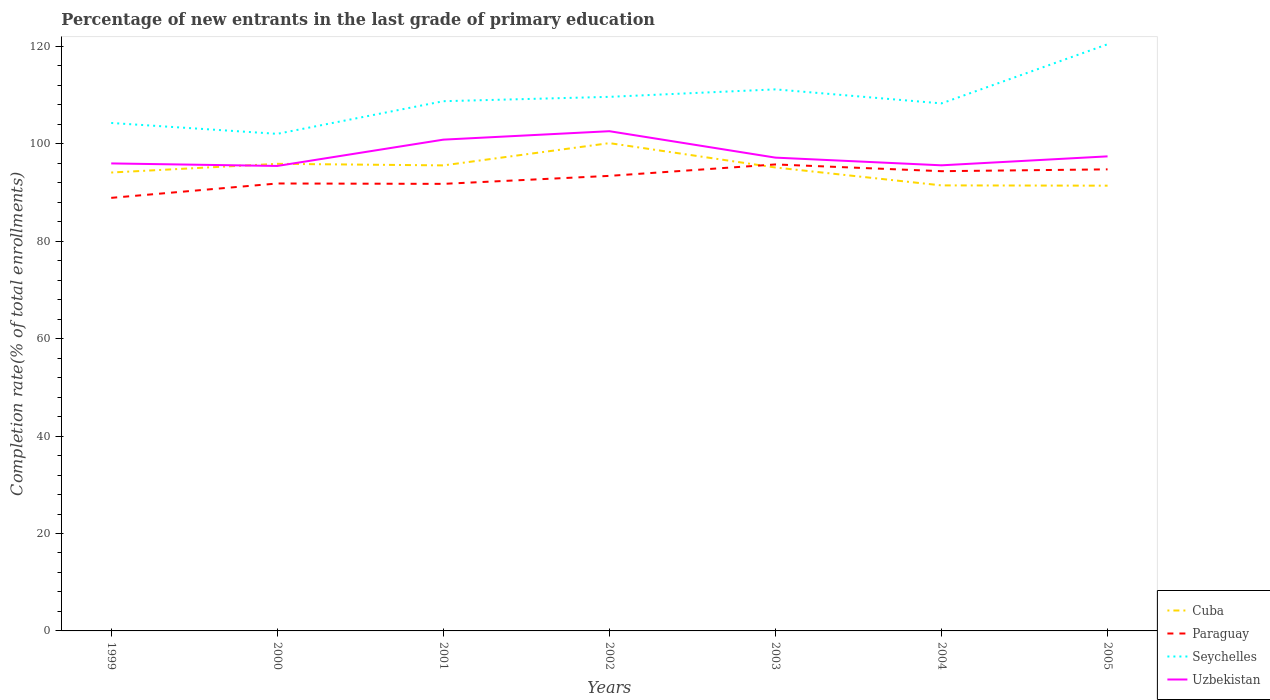How many different coloured lines are there?
Your answer should be compact. 4. Across all years, what is the maximum percentage of new entrants in Paraguay?
Provide a short and direct response. 88.92. In which year was the percentage of new entrants in Cuba maximum?
Keep it short and to the point. 2005. What is the total percentage of new entrants in Cuba in the graph?
Offer a very short reply. 4.11. What is the difference between the highest and the second highest percentage of new entrants in Paraguay?
Keep it short and to the point. 6.86. Is the percentage of new entrants in Uzbekistan strictly greater than the percentage of new entrants in Paraguay over the years?
Your response must be concise. No. Are the values on the major ticks of Y-axis written in scientific E-notation?
Provide a succinct answer. No. Where does the legend appear in the graph?
Offer a very short reply. Bottom right. What is the title of the graph?
Make the answer very short. Percentage of new entrants in the last grade of primary education. Does "Belgium" appear as one of the legend labels in the graph?
Offer a terse response. No. What is the label or title of the Y-axis?
Offer a terse response. Completion rate(% of total enrollments). What is the Completion rate(% of total enrollments) of Cuba in 1999?
Ensure brevity in your answer.  94.12. What is the Completion rate(% of total enrollments) in Paraguay in 1999?
Provide a succinct answer. 88.92. What is the Completion rate(% of total enrollments) in Seychelles in 1999?
Keep it short and to the point. 104.3. What is the Completion rate(% of total enrollments) of Uzbekistan in 1999?
Offer a terse response. 95.99. What is the Completion rate(% of total enrollments) in Cuba in 2000?
Provide a succinct answer. 95.91. What is the Completion rate(% of total enrollments) of Paraguay in 2000?
Provide a succinct answer. 91.87. What is the Completion rate(% of total enrollments) of Seychelles in 2000?
Provide a succinct answer. 102.06. What is the Completion rate(% of total enrollments) in Uzbekistan in 2000?
Offer a terse response. 95.47. What is the Completion rate(% of total enrollments) in Cuba in 2001?
Make the answer very short. 95.59. What is the Completion rate(% of total enrollments) in Paraguay in 2001?
Ensure brevity in your answer.  91.79. What is the Completion rate(% of total enrollments) in Seychelles in 2001?
Make the answer very short. 108.76. What is the Completion rate(% of total enrollments) in Uzbekistan in 2001?
Keep it short and to the point. 100.87. What is the Completion rate(% of total enrollments) in Cuba in 2002?
Ensure brevity in your answer.  100.16. What is the Completion rate(% of total enrollments) in Paraguay in 2002?
Ensure brevity in your answer.  93.43. What is the Completion rate(% of total enrollments) of Seychelles in 2002?
Ensure brevity in your answer.  109.66. What is the Completion rate(% of total enrollments) of Uzbekistan in 2002?
Keep it short and to the point. 102.61. What is the Completion rate(% of total enrollments) of Cuba in 2003?
Offer a very short reply. 95.15. What is the Completion rate(% of total enrollments) in Paraguay in 2003?
Offer a terse response. 95.78. What is the Completion rate(% of total enrollments) of Seychelles in 2003?
Make the answer very short. 111.19. What is the Completion rate(% of total enrollments) in Uzbekistan in 2003?
Your answer should be compact. 97.18. What is the Completion rate(% of total enrollments) in Cuba in 2004?
Provide a short and direct response. 91.48. What is the Completion rate(% of total enrollments) of Paraguay in 2004?
Provide a succinct answer. 94.4. What is the Completion rate(% of total enrollments) in Seychelles in 2004?
Provide a succinct answer. 108.32. What is the Completion rate(% of total enrollments) of Uzbekistan in 2004?
Provide a succinct answer. 95.6. What is the Completion rate(% of total enrollments) in Cuba in 2005?
Make the answer very short. 91.42. What is the Completion rate(% of total enrollments) of Paraguay in 2005?
Offer a terse response. 94.77. What is the Completion rate(% of total enrollments) of Seychelles in 2005?
Provide a succinct answer. 120.46. What is the Completion rate(% of total enrollments) of Uzbekistan in 2005?
Ensure brevity in your answer.  97.44. Across all years, what is the maximum Completion rate(% of total enrollments) of Cuba?
Ensure brevity in your answer.  100.16. Across all years, what is the maximum Completion rate(% of total enrollments) in Paraguay?
Provide a succinct answer. 95.78. Across all years, what is the maximum Completion rate(% of total enrollments) of Seychelles?
Provide a short and direct response. 120.46. Across all years, what is the maximum Completion rate(% of total enrollments) of Uzbekistan?
Ensure brevity in your answer.  102.61. Across all years, what is the minimum Completion rate(% of total enrollments) of Cuba?
Keep it short and to the point. 91.42. Across all years, what is the minimum Completion rate(% of total enrollments) in Paraguay?
Your answer should be compact. 88.92. Across all years, what is the minimum Completion rate(% of total enrollments) in Seychelles?
Provide a succinct answer. 102.06. Across all years, what is the minimum Completion rate(% of total enrollments) in Uzbekistan?
Make the answer very short. 95.47. What is the total Completion rate(% of total enrollments) of Cuba in the graph?
Provide a succinct answer. 663.83. What is the total Completion rate(% of total enrollments) in Paraguay in the graph?
Ensure brevity in your answer.  650.96. What is the total Completion rate(% of total enrollments) of Seychelles in the graph?
Your response must be concise. 764.75. What is the total Completion rate(% of total enrollments) of Uzbekistan in the graph?
Provide a succinct answer. 685.16. What is the difference between the Completion rate(% of total enrollments) in Cuba in 1999 and that in 2000?
Make the answer very short. -1.79. What is the difference between the Completion rate(% of total enrollments) in Paraguay in 1999 and that in 2000?
Offer a very short reply. -2.95. What is the difference between the Completion rate(% of total enrollments) in Seychelles in 1999 and that in 2000?
Your response must be concise. 2.23. What is the difference between the Completion rate(% of total enrollments) in Uzbekistan in 1999 and that in 2000?
Offer a terse response. 0.52. What is the difference between the Completion rate(% of total enrollments) of Cuba in 1999 and that in 2001?
Keep it short and to the point. -1.46. What is the difference between the Completion rate(% of total enrollments) of Paraguay in 1999 and that in 2001?
Give a very brief answer. -2.87. What is the difference between the Completion rate(% of total enrollments) in Seychelles in 1999 and that in 2001?
Provide a short and direct response. -4.47. What is the difference between the Completion rate(% of total enrollments) of Uzbekistan in 1999 and that in 2001?
Offer a terse response. -4.88. What is the difference between the Completion rate(% of total enrollments) of Cuba in 1999 and that in 2002?
Provide a succinct answer. -6.04. What is the difference between the Completion rate(% of total enrollments) of Paraguay in 1999 and that in 2002?
Your answer should be very brief. -4.51. What is the difference between the Completion rate(% of total enrollments) in Seychelles in 1999 and that in 2002?
Keep it short and to the point. -5.36. What is the difference between the Completion rate(% of total enrollments) of Uzbekistan in 1999 and that in 2002?
Your response must be concise. -6.62. What is the difference between the Completion rate(% of total enrollments) in Cuba in 1999 and that in 2003?
Provide a short and direct response. -1.03. What is the difference between the Completion rate(% of total enrollments) in Paraguay in 1999 and that in 2003?
Keep it short and to the point. -6.86. What is the difference between the Completion rate(% of total enrollments) in Seychelles in 1999 and that in 2003?
Provide a short and direct response. -6.9. What is the difference between the Completion rate(% of total enrollments) in Uzbekistan in 1999 and that in 2003?
Make the answer very short. -1.19. What is the difference between the Completion rate(% of total enrollments) of Cuba in 1999 and that in 2004?
Offer a very short reply. 2.64. What is the difference between the Completion rate(% of total enrollments) in Paraguay in 1999 and that in 2004?
Provide a succinct answer. -5.48. What is the difference between the Completion rate(% of total enrollments) of Seychelles in 1999 and that in 2004?
Offer a very short reply. -4.02. What is the difference between the Completion rate(% of total enrollments) in Uzbekistan in 1999 and that in 2004?
Your response must be concise. 0.39. What is the difference between the Completion rate(% of total enrollments) of Cuba in 1999 and that in 2005?
Keep it short and to the point. 2.7. What is the difference between the Completion rate(% of total enrollments) in Paraguay in 1999 and that in 2005?
Give a very brief answer. -5.85. What is the difference between the Completion rate(% of total enrollments) of Seychelles in 1999 and that in 2005?
Offer a terse response. -16.16. What is the difference between the Completion rate(% of total enrollments) in Uzbekistan in 1999 and that in 2005?
Make the answer very short. -1.45. What is the difference between the Completion rate(% of total enrollments) in Cuba in 2000 and that in 2001?
Ensure brevity in your answer.  0.32. What is the difference between the Completion rate(% of total enrollments) of Paraguay in 2000 and that in 2001?
Keep it short and to the point. 0.08. What is the difference between the Completion rate(% of total enrollments) in Seychelles in 2000 and that in 2001?
Provide a succinct answer. -6.7. What is the difference between the Completion rate(% of total enrollments) of Uzbekistan in 2000 and that in 2001?
Offer a terse response. -5.4. What is the difference between the Completion rate(% of total enrollments) of Cuba in 2000 and that in 2002?
Offer a very short reply. -4.25. What is the difference between the Completion rate(% of total enrollments) in Paraguay in 2000 and that in 2002?
Offer a very short reply. -1.56. What is the difference between the Completion rate(% of total enrollments) of Seychelles in 2000 and that in 2002?
Provide a short and direct response. -7.6. What is the difference between the Completion rate(% of total enrollments) in Uzbekistan in 2000 and that in 2002?
Your answer should be very brief. -7.14. What is the difference between the Completion rate(% of total enrollments) in Cuba in 2000 and that in 2003?
Your answer should be compact. 0.75. What is the difference between the Completion rate(% of total enrollments) of Paraguay in 2000 and that in 2003?
Provide a succinct answer. -3.91. What is the difference between the Completion rate(% of total enrollments) of Seychelles in 2000 and that in 2003?
Your response must be concise. -9.13. What is the difference between the Completion rate(% of total enrollments) of Uzbekistan in 2000 and that in 2003?
Keep it short and to the point. -1.71. What is the difference between the Completion rate(% of total enrollments) of Cuba in 2000 and that in 2004?
Provide a short and direct response. 4.43. What is the difference between the Completion rate(% of total enrollments) in Paraguay in 2000 and that in 2004?
Ensure brevity in your answer.  -2.53. What is the difference between the Completion rate(% of total enrollments) of Seychelles in 2000 and that in 2004?
Offer a terse response. -6.25. What is the difference between the Completion rate(% of total enrollments) of Uzbekistan in 2000 and that in 2004?
Keep it short and to the point. -0.13. What is the difference between the Completion rate(% of total enrollments) in Cuba in 2000 and that in 2005?
Provide a succinct answer. 4.48. What is the difference between the Completion rate(% of total enrollments) in Paraguay in 2000 and that in 2005?
Provide a succinct answer. -2.9. What is the difference between the Completion rate(% of total enrollments) in Seychelles in 2000 and that in 2005?
Provide a short and direct response. -18.39. What is the difference between the Completion rate(% of total enrollments) in Uzbekistan in 2000 and that in 2005?
Make the answer very short. -1.97. What is the difference between the Completion rate(% of total enrollments) in Cuba in 2001 and that in 2002?
Give a very brief answer. -4.57. What is the difference between the Completion rate(% of total enrollments) of Paraguay in 2001 and that in 2002?
Ensure brevity in your answer.  -1.64. What is the difference between the Completion rate(% of total enrollments) of Seychelles in 2001 and that in 2002?
Provide a short and direct response. -0.9. What is the difference between the Completion rate(% of total enrollments) in Uzbekistan in 2001 and that in 2002?
Provide a short and direct response. -1.73. What is the difference between the Completion rate(% of total enrollments) in Cuba in 2001 and that in 2003?
Offer a terse response. 0.43. What is the difference between the Completion rate(% of total enrollments) in Paraguay in 2001 and that in 2003?
Provide a short and direct response. -3.99. What is the difference between the Completion rate(% of total enrollments) in Seychelles in 2001 and that in 2003?
Give a very brief answer. -2.43. What is the difference between the Completion rate(% of total enrollments) in Uzbekistan in 2001 and that in 2003?
Ensure brevity in your answer.  3.69. What is the difference between the Completion rate(% of total enrollments) of Cuba in 2001 and that in 2004?
Your response must be concise. 4.11. What is the difference between the Completion rate(% of total enrollments) of Paraguay in 2001 and that in 2004?
Your response must be concise. -2.61. What is the difference between the Completion rate(% of total enrollments) of Seychelles in 2001 and that in 2004?
Give a very brief answer. 0.45. What is the difference between the Completion rate(% of total enrollments) in Uzbekistan in 2001 and that in 2004?
Your answer should be very brief. 5.27. What is the difference between the Completion rate(% of total enrollments) of Cuba in 2001 and that in 2005?
Provide a succinct answer. 4.16. What is the difference between the Completion rate(% of total enrollments) in Paraguay in 2001 and that in 2005?
Your answer should be very brief. -2.98. What is the difference between the Completion rate(% of total enrollments) of Seychelles in 2001 and that in 2005?
Provide a succinct answer. -11.69. What is the difference between the Completion rate(% of total enrollments) in Uzbekistan in 2001 and that in 2005?
Your answer should be compact. 3.43. What is the difference between the Completion rate(% of total enrollments) in Cuba in 2002 and that in 2003?
Your answer should be very brief. 5. What is the difference between the Completion rate(% of total enrollments) in Paraguay in 2002 and that in 2003?
Offer a very short reply. -2.35. What is the difference between the Completion rate(% of total enrollments) in Seychelles in 2002 and that in 2003?
Keep it short and to the point. -1.53. What is the difference between the Completion rate(% of total enrollments) of Uzbekistan in 2002 and that in 2003?
Your response must be concise. 5.43. What is the difference between the Completion rate(% of total enrollments) of Cuba in 2002 and that in 2004?
Offer a very short reply. 8.68. What is the difference between the Completion rate(% of total enrollments) in Paraguay in 2002 and that in 2004?
Offer a terse response. -0.96. What is the difference between the Completion rate(% of total enrollments) of Seychelles in 2002 and that in 2004?
Your answer should be compact. 1.34. What is the difference between the Completion rate(% of total enrollments) in Uzbekistan in 2002 and that in 2004?
Keep it short and to the point. 7.01. What is the difference between the Completion rate(% of total enrollments) of Cuba in 2002 and that in 2005?
Your answer should be very brief. 8.73. What is the difference between the Completion rate(% of total enrollments) in Paraguay in 2002 and that in 2005?
Offer a very short reply. -1.34. What is the difference between the Completion rate(% of total enrollments) of Seychelles in 2002 and that in 2005?
Ensure brevity in your answer.  -10.8. What is the difference between the Completion rate(% of total enrollments) of Uzbekistan in 2002 and that in 2005?
Your answer should be compact. 5.17. What is the difference between the Completion rate(% of total enrollments) of Cuba in 2003 and that in 2004?
Give a very brief answer. 3.68. What is the difference between the Completion rate(% of total enrollments) of Paraguay in 2003 and that in 2004?
Offer a terse response. 1.38. What is the difference between the Completion rate(% of total enrollments) in Seychelles in 2003 and that in 2004?
Your answer should be compact. 2.88. What is the difference between the Completion rate(% of total enrollments) of Uzbekistan in 2003 and that in 2004?
Ensure brevity in your answer.  1.58. What is the difference between the Completion rate(% of total enrollments) in Cuba in 2003 and that in 2005?
Offer a very short reply. 3.73. What is the difference between the Completion rate(% of total enrollments) of Paraguay in 2003 and that in 2005?
Offer a very short reply. 1.01. What is the difference between the Completion rate(% of total enrollments) in Seychelles in 2003 and that in 2005?
Keep it short and to the point. -9.26. What is the difference between the Completion rate(% of total enrollments) of Uzbekistan in 2003 and that in 2005?
Your response must be concise. -0.26. What is the difference between the Completion rate(% of total enrollments) in Cuba in 2004 and that in 2005?
Make the answer very short. 0.06. What is the difference between the Completion rate(% of total enrollments) in Paraguay in 2004 and that in 2005?
Your answer should be compact. -0.37. What is the difference between the Completion rate(% of total enrollments) of Seychelles in 2004 and that in 2005?
Your response must be concise. -12.14. What is the difference between the Completion rate(% of total enrollments) in Uzbekistan in 2004 and that in 2005?
Your answer should be very brief. -1.84. What is the difference between the Completion rate(% of total enrollments) in Cuba in 1999 and the Completion rate(% of total enrollments) in Paraguay in 2000?
Provide a short and direct response. 2.25. What is the difference between the Completion rate(% of total enrollments) of Cuba in 1999 and the Completion rate(% of total enrollments) of Seychelles in 2000?
Make the answer very short. -7.94. What is the difference between the Completion rate(% of total enrollments) of Cuba in 1999 and the Completion rate(% of total enrollments) of Uzbekistan in 2000?
Ensure brevity in your answer.  -1.35. What is the difference between the Completion rate(% of total enrollments) of Paraguay in 1999 and the Completion rate(% of total enrollments) of Seychelles in 2000?
Provide a succinct answer. -13.14. What is the difference between the Completion rate(% of total enrollments) of Paraguay in 1999 and the Completion rate(% of total enrollments) of Uzbekistan in 2000?
Your answer should be very brief. -6.55. What is the difference between the Completion rate(% of total enrollments) in Seychelles in 1999 and the Completion rate(% of total enrollments) in Uzbekistan in 2000?
Your answer should be very brief. 8.83. What is the difference between the Completion rate(% of total enrollments) in Cuba in 1999 and the Completion rate(% of total enrollments) in Paraguay in 2001?
Make the answer very short. 2.33. What is the difference between the Completion rate(% of total enrollments) in Cuba in 1999 and the Completion rate(% of total enrollments) in Seychelles in 2001?
Give a very brief answer. -14.64. What is the difference between the Completion rate(% of total enrollments) of Cuba in 1999 and the Completion rate(% of total enrollments) of Uzbekistan in 2001?
Make the answer very short. -6.75. What is the difference between the Completion rate(% of total enrollments) in Paraguay in 1999 and the Completion rate(% of total enrollments) in Seychelles in 2001?
Provide a succinct answer. -19.84. What is the difference between the Completion rate(% of total enrollments) in Paraguay in 1999 and the Completion rate(% of total enrollments) in Uzbekistan in 2001?
Your response must be concise. -11.95. What is the difference between the Completion rate(% of total enrollments) of Seychelles in 1999 and the Completion rate(% of total enrollments) of Uzbekistan in 2001?
Your answer should be very brief. 3.43. What is the difference between the Completion rate(% of total enrollments) in Cuba in 1999 and the Completion rate(% of total enrollments) in Paraguay in 2002?
Make the answer very short. 0.69. What is the difference between the Completion rate(% of total enrollments) of Cuba in 1999 and the Completion rate(% of total enrollments) of Seychelles in 2002?
Offer a very short reply. -15.54. What is the difference between the Completion rate(% of total enrollments) in Cuba in 1999 and the Completion rate(% of total enrollments) in Uzbekistan in 2002?
Make the answer very short. -8.49. What is the difference between the Completion rate(% of total enrollments) of Paraguay in 1999 and the Completion rate(% of total enrollments) of Seychelles in 2002?
Offer a terse response. -20.74. What is the difference between the Completion rate(% of total enrollments) of Paraguay in 1999 and the Completion rate(% of total enrollments) of Uzbekistan in 2002?
Keep it short and to the point. -13.69. What is the difference between the Completion rate(% of total enrollments) of Seychelles in 1999 and the Completion rate(% of total enrollments) of Uzbekistan in 2002?
Offer a very short reply. 1.69. What is the difference between the Completion rate(% of total enrollments) in Cuba in 1999 and the Completion rate(% of total enrollments) in Paraguay in 2003?
Provide a short and direct response. -1.66. What is the difference between the Completion rate(% of total enrollments) in Cuba in 1999 and the Completion rate(% of total enrollments) in Seychelles in 2003?
Offer a very short reply. -17.07. What is the difference between the Completion rate(% of total enrollments) in Cuba in 1999 and the Completion rate(% of total enrollments) in Uzbekistan in 2003?
Offer a terse response. -3.06. What is the difference between the Completion rate(% of total enrollments) of Paraguay in 1999 and the Completion rate(% of total enrollments) of Seychelles in 2003?
Give a very brief answer. -22.27. What is the difference between the Completion rate(% of total enrollments) in Paraguay in 1999 and the Completion rate(% of total enrollments) in Uzbekistan in 2003?
Provide a short and direct response. -8.26. What is the difference between the Completion rate(% of total enrollments) in Seychelles in 1999 and the Completion rate(% of total enrollments) in Uzbekistan in 2003?
Give a very brief answer. 7.12. What is the difference between the Completion rate(% of total enrollments) in Cuba in 1999 and the Completion rate(% of total enrollments) in Paraguay in 2004?
Provide a short and direct response. -0.28. What is the difference between the Completion rate(% of total enrollments) in Cuba in 1999 and the Completion rate(% of total enrollments) in Seychelles in 2004?
Ensure brevity in your answer.  -14.2. What is the difference between the Completion rate(% of total enrollments) of Cuba in 1999 and the Completion rate(% of total enrollments) of Uzbekistan in 2004?
Give a very brief answer. -1.48. What is the difference between the Completion rate(% of total enrollments) in Paraguay in 1999 and the Completion rate(% of total enrollments) in Seychelles in 2004?
Provide a short and direct response. -19.4. What is the difference between the Completion rate(% of total enrollments) of Paraguay in 1999 and the Completion rate(% of total enrollments) of Uzbekistan in 2004?
Give a very brief answer. -6.68. What is the difference between the Completion rate(% of total enrollments) of Seychelles in 1999 and the Completion rate(% of total enrollments) of Uzbekistan in 2004?
Your answer should be compact. 8.7. What is the difference between the Completion rate(% of total enrollments) of Cuba in 1999 and the Completion rate(% of total enrollments) of Paraguay in 2005?
Provide a succinct answer. -0.65. What is the difference between the Completion rate(% of total enrollments) of Cuba in 1999 and the Completion rate(% of total enrollments) of Seychelles in 2005?
Provide a succinct answer. -26.34. What is the difference between the Completion rate(% of total enrollments) of Cuba in 1999 and the Completion rate(% of total enrollments) of Uzbekistan in 2005?
Your answer should be very brief. -3.32. What is the difference between the Completion rate(% of total enrollments) of Paraguay in 1999 and the Completion rate(% of total enrollments) of Seychelles in 2005?
Provide a short and direct response. -31.54. What is the difference between the Completion rate(% of total enrollments) in Paraguay in 1999 and the Completion rate(% of total enrollments) in Uzbekistan in 2005?
Offer a very short reply. -8.52. What is the difference between the Completion rate(% of total enrollments) in Seychelles in 1999 and the Completion rate(% of total enrollments) in Uzbekistan in 2005?
Your answer should be compact. 6.86. What is the difference between the Completion rate(% of total enrollments) of Cuba in 2000 and the Completion rate(% of total enrollments) of Paraguay in 2001?
Your answer should be compact. 4.12. What is the difference between the Completion rate(% of total enrollments) in Cuba in 2000 and the Completion rate(% of total enrollments) in Seychelles in 2001?
Keep it short and to the point. -12.86. What is the difference between the Completion rate(% of total enrollments) in Cuba in 2000 and the Completion rate(% of total enrollments) in Uzbekistan in 2001?
Provide a succinct answer. -4.96. What is the difference between the Completion rate(% of total enrollments) of Paraguay in 2000 and the Completion rate(% of total enrollments) of Seychelles in 2001?
Your response must be concise. -16.89. What is the difference between the Completion rate(% of total enrollments) in Paraguay in 2000 and the Completion rate(% of total enrollments) in Uzbekistan in 2001?
Ensure brevity in your answer.  -9. What is the difference between the Completion rate(% of total enrollments) of Seychelles in 2000 and the Completion rate(% of total enrollments) of Uzbekistan in 2001?
Make the answer very short. 1.19. What is the difference between the Completion rate(% of total enrollments) of Cuba in 2000 and the Completion rate(% of total enrollments) of Paraguay in 2002?
Your answer should be very brief. 2.47. What is the difference between the Completion rate(% of total enrollments) of Cuba in 2000 and the Completion rate(% of total enrollments) of Seychelles in 2002?
Offer a very short reply. -13.75. What is the difference between the Completion rate(% of total enrollments) of Cuba in 2000 and the Completion rate(% of total enrollments) of Uzbekistan in 2002?
Provide a succinct answer. -6.7. What is the difference between the Completion rate(% of total enrollments) in Paraguay in 2000 and the Completion rate(% of total enrollments) in Seychelles in 2002?
Provide a short and direct response. -17.79. What is the difference between the Completion rate(% of total enrollments) in Paraguay in 2000 and the Completion rate(% of total enrollments) in Uzbekistan in 2002?
Your answer should be compact. -10.74. What is the difference between the Completion rate(% of total enrollments) in Seychelles in 2000 and the Completion rate(% of total enrollments) in Uzbekistan in 2002?
Make the answer very short. -0.54. What is the difference between the Completion rate(% of total enrollments) in Cuba in 2000 and the Completion rate(% of total enrollments) in Paraguay in 2003?
Your answer should be compact. 0.13. What is the difference between the Completion rate(% of total enrollments) of Cuba in 2000 and the Completion rate(% of total enrollments) of Seychelles in 2003?
Your answer should be compact. -15.29. What is the difference between the Completion rate(% of total enrollments) of Cuba in 2000 and the Completion rate(% of total enrollments) of Uzbekistan in 2003?
Your response must be concise. -1.27. What is the difference between the Completion rate(% of total enrollments) of Paraguay in 2000 and the Completion rate(% of total enrollments) of Seychelles in 2003?
Offer a very short reply. -19.32. What is the difference between the Completion rate(% of total enrollments) of Paraguay in 2000 and the Completion rate(% of total enrollments) of Uzbekistan in 2003?
Offer a terse response. -5.31. What is the difference between the Completion rate(% of total enrollments) of Seychelles in 2000 and the Completion rate(% of total enrollments) of Uzbekistan in 2003?
Your answer should be compact. 4.88. What is the difference between the Completion rate(% of total enrollments) of Cuba in 2000 and the Completion rate(% of total enrollments) of Paraguay in 2004?
Make the answer very short. 1.51. What is the difference between the Completion rate(% of total enrollments) of Cuba in 2000 and the Completion rate(% of total enrollments) of Seychelles in 2004?
Provide a short and direct response. -12.41. What is the difference between the Completion rate(% of total enrollments) of Cuba in 2000 and the Completion rate(% of total enrollments) of Uzbekistan in 2004?
Give a very brief answer. 0.31. What is the difference between the Completion rate(% of total enrollments) of Paraguay in 2000 and the Completion rate(% of total enrollments) of Seychelles in 2004?
Ensure brevity in your answer.  -16.45. What is the difference between the Completion rate(% of total enrollments) of Paraguay in 2000 and the Completion rate(% of total enrollments) of Uzbekistan in 2004?
Give a very brief answer. -3.73. What is the difference between the Completion rate(% of total enrollments) of Seychelles in 2000 and the Completion rate(% of total enrollments) of Uzbekistan in 2004?
Your response must be concise. 6.46. What is the difference between the Completion rate(% of total enrollments) in Cuba in 2000 and the Completion rate(% of total enrollments) in Paraguay in 2005?
Keep it short and to the point. 1.14. What is the difference between the Completion rate(% of total enrollments) in Cuba in 2000 and the Completion rate(% of total enrollments) in Seychelles in 2005?
Keep it short and to the point. -24.55. What is the difference between the Completion rate(% of total enrollments) in Cuba in 2000 and the Completion rate(% of total enrollments) in Uzbekistan in 2005?
Ensure brevity in your answer.  -1.53. What is the difference between the Completion rate(% of total enrollments) in Paraguay in 2000 and the Completion rate(% of total enrollments) in Seychelles in 2005?
Offer a terse response. -28.59. What is the difference between the Completion rate(% of total enrollments) of Paraguay in 2000 and the Completion rate(% of total enrollments) of Uzbekistan in 2005?
Offer a very short reply. -5.57. What is the difference between the Completion rate(% of total enrollments) in Seychelles in 2000 and the Completion rate(% of total enrollments) in Uzbekistan in 2005?
Make the answer very short. 4.62. What is the difference between the Completion rate(% of total enrollments) in Cuba in 2001 and the Completion rate(% of total enrollments) in Paraguay in 2002?
Provide a succinct answer. 2.15. What is the difference between the Completion rate(% of total enrollments) of Cuba in 2001 and the Completion rate(% of total enrollments) of Seychelles in 2002?
Your response must be concise. -14.07. What is the difference between the Completion rate(% of total enrollments) of Cuba in 2001 and the Completion rate(% of total enrollments) of Uzbekistan in 2002?
Offer a terse response. -7.02. What is the difference between the Completion rate(% of total enrollments) in Paraguay in 2001 and the Completion rate(% of total enrollments) in Seychelles in 2002?
Your answer should be very brief. -17.87. What is the difference between the Completion rate(% of total enrollments) of Paraguay in 2001 and the Completion rate(% of total enrollments) of Uzbekistan in 2002?
Provide a short and direct response. -10.81. What is the difference between the Completion rate(% of total enrollments) of Seychelles in 2001 and the Completion rate(% of total enrollments) of Uzbekistan in 2002?
Ensure brevity in your answer.  6.16. What is the difference between the Completion rate(% of total enrollments) in Cuba in 2001 and the Completion rate(% of total enrollments) in Paraguay in 2003?
Ensure brevity in your answer.  -0.2. What is the difference between the Completion rate(% of total enrollments) of Cuba in 2001 and the Completion rate(% of total enrollments) of Seychelles in 2003?
Your response must be concise. -15.61. What is the difference between the Completion rate(% of total enrollments) in Cuba in 2001 and the Completion rate(% of total enrollments) in Uzbekistan in 2003?
Keep it short and to the point. -1.59. What is the difference between the Completion rate(% of total enrollments) of Paraguay in 2001 and the Completion rate(% of total enrollments) of Seychelles in 2003?
Ensure brevity in your answer.  -19.4. What is the difference between the Completion rate(% of total enrollments) in Paraguay in 2001 and the Completion rate(% of total enrollments) in Uzbekistan in 2003?
Your answer should be compact. -5.39. What is the difference between the Completion rate(% of total enrollments) in Seychelles in 2001 and the Completion rate(% of total enrollments) in Uzbekistan in 2003?
Keep it short and to the point. 11.58. What is the difference between the Completion rate(% of total enrollments) of Cuba in 2001 and the Completion rate(% of total enrollments) of Paraguay in 2004?
Provide a short and direct response. 1.19. What is the difference between the Completion rate(% of total enrollments) of Cuba in 2001 and the Completion rate(% of total enrollments) of Seychelles in 2004?
Offer a very short reply. -12.73. What is the difference between the Completion rate(% of total enrollments) in Cuba in 2001 and the Completion rate(% of total enrollments) in Uzbekistan in 2004?
Keep it short and to the point. -0.01. What is the difference between the Completion rate(% of total enrollments) of Paraguay in 2001 and the Completion rate(% of total enrollments) of Seychelles in 2004?
Your answer should be compact. -16.52. What is the difference between the Completion rate(% of total enrollments) of Paraguay in 2001 and the Completion rate(% of total enrollments) of Uzbekistan in 2004?
Provide a succinct answer. -3.81. What is the difference between the Completion rate(% of total enrollments) in Seychelles in 2001 and the Completion rate(% of total enrollments) in Uzbekistan in 2004?
Ensure brevity in your answer.  13.16. What is the difference between the Completion rate(% of total enrollments) of Cuba in 2001 and the Completion rate(% of total enrollments) of Paraguay in 2005?
Provide a succinct answer. 0.81. What is the difference between the Completion rate(% of total enrollments) of Cuba in 2001 and the Completion rate(% of total enrollments) of Seychelles in 2005?
Give a very brief answer. -24.87. What is the difference between the Completion rate(% of total enrollments) in Cuba in 2001 and the Completion rate(% of total enrollments) in Uzbekistan in 2005?
Provide a succinct answer. -1.85. What is the difference between the Completion rate(% of total enrollments) in Paraguay in 2001 and the Completion rate(% of total enrollments) in Seychelles in 2005?
Ensure brevity in your answer.  -28.67. What is the difference between the Completion rate(% of total enrollments) of Paraguay in 2001 and the Completion rate(% of total enrollments) of Uzbekistan in 2005?
Keep it short and to the point. -5.65. What is the difference between the Completion rate(% of total enrollments) in Seychelles in 2001 and the Completion rate(% of total enrollments) in Uzbekistan in 2005?
Your answer should be very brief. 11.32. What is the difference between the Completion rate(% of total enrollments) of Cuba in 2002 and the Completion rate(% of total enrollments) of Paraguay in 2003?
Offer a terse response. 4.38. What is the difference between the Completion rate(% of total enrollments) of Cuba in 2002 and the Completion rate(% of total enrollments) of Seychelles in 2003?
Offer a very short reply. -11.04. What is the difference between the Completion rate(% of total enrollments) in Cuba in 2002 and the Completion rate(% of total enrollments) in Uzbekistan in 2003?
Keep it short and to the point. 2.98. What is the difference between the Completion rate(% of total enrollments) in Paraguay in 2002 and the Completion rate(% of total enrollments) in Seychelles in 2003?
Make the answer very short. -17.76. What is the difference between the Completion rate(% of total enrollments) of Paraguay in 2002 and the Completion rate(% of total enrollments) of Uzbekistan in 2003?
Offer a terse response. -3.74. What is the difference between the Completion rate(% of total enrollments) in Seychelles in 2002 and the Completion rate(% of total enrollments) in Uzbekistan in 2003?
Your answer should be compact. 12.48. What is the difference between the Completion rate(% of total enrollments) of Cuba in 2002 and the Completion rate(% of total enrollments) of Paraguay in 2004?
Give a very brief answer. 5.76. What is the difference between the Completion rate(% of total enrollments) of Cuba in 2002 and the Completion rate(% of total enrollments) of Seychelles in 2004?
Your answer should be compact. -8.16. What is the difference between the Completion rate(% of total enrollments) in Cuba in 2002 and the Completion rate(% of total enrollments) in Uzbekistan in 2004?
Provide a succinct answer. 4.56. What is the difference between the Completion rate(% of total enrollments) in Paraguay in 2002 and the Completion rate(% of total enrollments) in Seychelles in 2004?
Your response must be concise. -14.88. What is the difference between the Completion rate(% of total enrollments) in Paraguay in 2002 and the Completion rate(% of total enrollments) in Uzbekistan in 2004?
Your answer should be very brief. -2.17. What is the difference between the Completion rate(% of total enrollments) of Seychelles in 2002 and the Completion rate(% of total enrollments) of Uzbekistan in 2004?
Ensure brevity in your answer.  14.06. What is the difference between the Completion rate(% of total enrollments) in Cuba in 2002 and the Completion rate(% of total enrollments) in Paraguay in 2005?
Keep it short and to the point. 5.39. What is the difference between the Completion rate(% of total enrollments) of Cuba in 2002 and the Completion rate(% of total enrollments) of Seychelles in 2005?
Your answer should be very brief. -20.3. What is the difference between the Completion rate(% of total enrollments) of Cuba in 2002 and the Completion rate(% of total enrollments) of Uzbekistan in 2005?
Offer a very short reply. 2.72. What is the difference between the Completion rate(% of total enrollments) of Paraguay in 2002 and the Completion rate(% of total enrollments) of Seychelles in 2005?
Your answer should be very brief. -27.02. What is the difference between the Completion rate(% of total enrollments) in Paraguay in 2002 and the Completion rate(% of total enrollments) in Uzbekistan in 2005?
Make the answer very short. -4.01. What is the difference between the Completion rate(% of total enrollments) of Seychelles in 2002 and the Completion rate(% of total enrollments) of Uzbekistan in 2005?
Offer a very short reply. 12.22. What is the difference between the Completion rate(% of total enrollments) in Cuba in 2003 and the Completion rate(% of total enrollments) in Paraguay in 2004?
Provide a short and direct response. 0.76. What is the difference between the Completion rate(% of total enrollments) in Cuba in 2003 and the Completion rate(% of total enrollments) in Seychelles in 2004?
Make the answer very short. -13.16. What is the difference between the Completion rate(% of total enrollments) of Cuba in 2003 and the Completion rate(% of total enrollments) of Uzbekistan in 2004?
Keep it short and to the point. -0.45. What is the difference between the Completion rate(% of total enrollments) in Paraguay in 2003 and the Completion rate(% of total enrollments) in Seychelles in 2004?
Your response must be concise. -12.54. What is the difference between the Completion rate(% of total enrollments) in Paraguay in 2003 and the Completion rate(% of total enrollments) in Uzbekistan in 2004?
Provide a succinct answer. 0.18. What is the difference between the Completion rate(% of total enrollments) of Seychelles in 2003 and the Completion rate(% of total enrollments) of Uzbekistan in 2004?
Ensure brevity in your answer.  15.59. What is the difference between the Completion rate(% of total enrollments) of Cuba in 2003 and the Completion rate(% of total enrollments) of Paraguay in 2005?
Ensure brevity in your answer.  0.38. What is the difference between the Completion rate(% of total enrollments) of Cuba in 2003 and the Completion rate(% of total enrollments) of Seychelles in 2005?
Offer a very short reply. -25.3. What is the difference between the Completion rate(% of total enrollments) in Cuba in 2003 and the Completion rate(% of total enrollments) in Uzbekistan in 2005?
Offer a terse response. -2.29. What is the difference between the Completion rate(% of total enrollments) of Paraguay in 2003 and the Completion rate(% of total enrollments) of Seychelles in 2005?
Provide a short and direct response. -24.68. What is the difference between the Completion rate(% of total enrollments) of Paraguay in 2003 and the Completion rate(% of total enrollments) of Uzbekistan in 2005?
Offer a terse response. -1.66. What is the difference between the Completion rate(% of total enrollments) in Seychelles in 2003 and the Completion rate(% of total enrollments) in Uzbekistan in 2005?
Offer a terse response. 13.75. What is the difference between the Completion rate(% of total enrollments) of Cuba in 2004 and the Completion rate(% of total enrollments) of Paraguay in 2005?
Keep it short and to the point. -3.29. What is the difference between the Completion rate(% of total enrollments) in Cuba in 2004 and the Completion rate(% of total enrollments) in Seychelles in 2005?
Give a very brief answer. -28.98. What is the difference between the Completion rate(% of total enrollments) in Cuba in 2004 and the Completion rate(% of total enrollments) in Uzbekistan in 2005?
Provide a succinct answer. -5.96. What is the difference between the Completion rate(% of total enrollments) in Paraguay in 2004 and the Completion rate(% of total enrollments) in Seychelles in 2005?
Your answer should be very brief. -26.06. What is the difference between the Completion rate(% of total enrollments) in Paraguay in 2004 and the Completion rate(% of total enrollments) in Uzbekistan in 2005?
Give a very brief answer. -3.04. What is the difference between the Completion rate(% of total enrollments) of Seychelles in 2004 and the Completion rate(% of total enrollments) of Uzbekistan in 2005?
Offer a very short reply. 10.88. What is the average Completion rate(% of total enrollments) of Cuba per year?
Your answer should be very brief. 94.83. What is the average Completion rate(% of total enrollments) in Paraguay per year?
Make the answer very short. 92.99. What is the average Completion rate(% of total enrollments) of Seychelles per year?
Offer a very short reply. 109.25. What is the average Completion rate(% of total enrollments) of Uzbekistan per year?
Offer a very short reply. 97.88. In the year 1999, what is the difference between the Completion rate(% of total enrollments) in Cuba and Completion rate(% of total enrollments) in Paraguay?
Offer a terse response. 5.2. In the year 1999, what is the difference between the Completion rate(% of total enrollments) in Cuba and Completion rate(% of total enrollments) in Seychelles?
Keep it short and to the point. -10.18. In the year 1999, what is the difference between the Completion rate(% of total enrollments) of Cuba and Completion rate(% of total enrollments) of Uzbekistan?
Make the answer very short. -1.87. In the year 1999, what is the difference between the Completion rate(% of total enrollments) in Paraguay and Completion rate(% of total enrollments) in Seychelles?
Provide a succinct answer. -15.38. In the year 1999, what is the difference between the Completion rate(% of total enrollments) of Paraguay and Completion rate(% of total enrollments) of Uzbekistan?
Your response must be concise. -7.07. In the year 1999, what is the difference between the Completion rate(% of total enrollments) of Seychelles and Completion rate(% of total enrollments) of Uzbekistan?
Your answer should be very brief. 8.31. In the year 2000, what is the difference between the Completion rate(% of total enrollments) in Cuba and Completion rate(% of total enrollments) in Paraguay?
Your response must be concise. 4.04. In the year 2000, what is the difference between the Completion rate(% of total enrollments) of Cuba and Completion rate(% of total enrollments) of Seychelles?
Provide a succinct answer. -6.16. In the year 2000, what is the difference between the Completion rate(% of total enrollments) in Cuba and Completion rate(% of total enrollments) in Uzbekistan?
Your answer should be very brief. 0.44. In the year 2000, what is the difference between the Completion rate(% of total enrollments) of Paraguay and Completion rate(% of total enrollments) of Seychelles?
Make the answer very short. -10.19. In the year 2000, what is the difference between the Completion rate(% of total enrollments) in Paraguay and Completion rate(% of total enrollments) in Uzbekistan?
Your answer should be very brief. -3.6. In the year 2000, what is the difference between the Completion rate(% of total enrollments) of Seychelles and Completion rate(% of total enrollments) of Uzbekistan?
Provide a short and direct response. 6.59. In the year 2001, what is the difference between the Completion rate(% of total enrollments) of Cuba and Completion rate(% of total enrollments) of Paraguay?
Your answer should be very brief. 3.79. In the year 2001, what is the difference between the Completion rate(% of total enrollments) in Cuba and Completion rate(% of total enrollments) in Seychelles?
Give a very brief answer. -13.18. In the year 2001, what is the difference between the Completion rate(% of total enrollments) in Cuba and Completion rate(% of total enrollments) in Uzbekistan?
Your answer should be very brief. -5.29. In the year 2001, what is the difference between the Completion rate(% of total enrollments) of Paraguay and Completion rate(% of total enrollments) of Seychelles?
Provide a short and direct response. -16.97. In the year 2001, what is the difference between the Completion rate(% of total enrollments) in Paraguay and Completion rate(% of total enrollments) in Uzbekistan?
Ensure brevity in your answer.  -9.08. In the year 2001, what is the difference between the Completion rate(% of total enrollments) in Seychelles and Completion rate(% of total enrollments) in Uzbekistan?
Keep it short and to the point. 7.89. In the year 2002, what is the difference between the Completion rate(% of total enrollments) in Cuba and Completion rate(% of total enrollments) in Paraguay?
Your answer should be compact. 6.72. In the year 2002, what is the difference between the Completion rate(% of total enrollments) of Cuba and Completion rate(% of total enrollments) of Seychelles?
Ensure brevity in your answer.  -9.5. In the year 2002, what is the difference between the Completion rate(% of total enrollments) in Cuba and Completion rate(% of total enrollments) in Uzbekistan?
Your response must be concise. -2.45. In the year 2002, what is the difference between the Completion rate(% of total enrollments) of Paraguay and Completion rate(% of total enrollments) of Seychelles?
Your response must be concise. -16.23. In the year 2002, what is the difference between the Completion rate(% of total enrollments) of Paraguay and Completion rate(% of total enrollments) of Uzbekistan?
Offer a terse response. -9.17. In the year 2002, what is the difference between the Completion rate(% of total enrollments) of Seychelles and Completion rate(% of total enrollments) of Uzbekistan?
Your response must be concise. 7.05. In the year 2003, what is the difference between the Completion rate(% of total enrollments) of Cuba and Completion rate(% of total enrollments) of Paraguay?
Your answer should be compact. -0.63. In the year 2003, what is the difference between the Completion rate(% of total enrollments) of Cuba and Completion rate(% of total enrollments) of Seychelles?
Your answer should be very brief. -16.04. In the year 2003, what is the difference between the Completion rate(% of total enrollments) in Cuba and Completion rate(% of total enrollments) in Uzbekistan?
Ensure brevity in your answer.  -2.03. In the year 2003, what is the difference between the Completion rate(% of total enrollments) of Paraguay and Completion rate(% of total enrollments) of Seychelles?
Offer a terse response. -15.41. In the year 2003, what is the difference between the Completion rate(% of total enrollments) of Paraguay and Completion rate(% of total enrollments) of Uzbekistan?
Give a very brief answer. -1.4. In the year 2003, what is the difference between the Completion rate(% of total enrollments) of Seychelles and Completion rate(% of total enrollments) of Uzbekistan?
Your response must be concise. 14.02. In the year 2004, what is the difference between the Completion rate(% of total enrollments) in Cuba and Completion rate(% of total enrollments) in Paraguay?
Give a very brief answer. -2.92. In the year 2004, what is the difference between the Completion rate(% of total enrollments) in Cuba and Completion rate(% of total enrollments) in Seychelles?
Keep it short and to the point. -16.84. In the year 2004, what is the difference between the Completion rate(% of total enrollments) of Cuba and Completion rate(% of total enrollments) of Uzbekistan?
Give a very brief answer. -4.12. In the year 2004, what is the difference between the Completion rate(% of total enrollments) in Paraguay and Completion rate(% of total enrollments) in Seychelles?
Make the answer very short. -13.92. In the year 2004, what is the difference between the Completion rate(% of total enrollments) of Paraguay and Completion rate(% of total enrollments) of Uzbekistan?
Offer a very short reply. -1.2. In the year 2004, what is the difference between the Completion rate(% of total enrollments) of Seychelles and Completion rate(% of total enrollments) of Uzbekistan?
Ensure brevity in your answer.  12.72. In the year 2005, what is the difference between the Completion rate(% of total enrollments) in Cuba and Completion rate(% of total enrollments) in Paraguay?
Offer a terse response. -3.35. In the year 2005, what is the difference between the Completion rate(% of total enrollments) in Cuba and Completion rate(% of total enrollments) in Seychelles?
Your response must be concise. -29.04. In the year 2005, what is the difference between the Completion rate(% of total enrollments) in Cuba and Completion rate(% of total enrollments) in Uzbekistan?
Provide a succinct answer. -6.02. In the year 2005, what is the difference between the Completion rate(% of total enrollments) of Paraguay and Completion rate(% of total enrollments) of Seychelles?
Provide a short and direct response. -25.69. In the year 2005, what is the difference between the Completion rate(% of total enrollments) in Paraguay and Completion rate(% of total enrollments) in Uzbekistan?
Your answer should be very brief. -2.67. In the year 2005, what is the difference between the Completion rate(% of total enrollments) in Seychelles and Completion rate(% of total enrollments) in Uzbekistan?
Make the answer very short. 23.02. What is the ratio of the Completion rate(% of total enrollments) of Cuba in 1999 to that in 2000?
Your answer should be very brief. 0.98. What is the ratio of the Completion rate(% of total enrollments) of Paraguay in 1999 to that in 2000?
Offer a terse response. 0.97. What is the ratio of the Completion rate(% of total enrollments) of Seychelles in 1999 to that in 2000?
Your answer should be very brief. 1.02. What is the ratio of the Completion rate(% of total enrollments) of Uzbekistan in 1999 to that in 2000?
Give a very brief answer. 1.01. What is the ratio of the Completion rate(% of total enrollments) of Cuba in 1999 to that in 2001?
Your answer should be compact. 0.98. What is the ratio of the Completion rate(% of total enrollments) of Paraguay in 1999 to that in 2001?
Provide a succinct answer. 0.97. What is the ratio of the Completion rate(% of total enrollments) in Seychelles in 1999 to that in 2001?
Ensure brevity in your answer.  0.96. What is the ratio of the Completion rate(% of total enrollments) of Uzbekistan in 1999 to that in 2001?
Ensure brevity in your answer.  0.95. What is the ratio of the Completion rate(% of total enrollments) of Cuba in 1999 to that in 2002?
Offer a very short reply. 0.94. What is the ratio of the Completion rate(% of total enrollments) in Paraguay in 1999 to that in 2002?
Offer a terse response. 0.95. What is the ratio of the Completion rate(% of total enrollments) in Seychelles in 1999 to that in 2002?
Your answer should be very brief. 0.95. What is the ratio of the Completion rate(% of total enrollments) in Uzbekistan in 1999 to that in 2002?
Offer a terse response. 0.94. What is the ratio of the Completion rate(% of total enrollments) of Paraguay in 1999 to that in 2003?
Provide a short and direct response. 0.93. What is the ratio of the Completion rate(% of total enrollments) of Seychelles in 1999 to that in 2003?
Provide a succinct answer. 0.94. What is the ratio of the Completion rate(% of total enrollments) in Uzbekistan in 1999 to that in 2003?
Offer a very short reply. 0.99. What is the ratio of the Completion rate(% of total enrollments) in Cuba in 1999 to that in 2004?
Provide a succinct answer. 1.03. What is the ratio of the Completion rate(% of total enrollments) in Paraguay in 1999 to that in 2004?
Provide a short and direct response. 0.94. What is the ratio of the Completion rate(% of total enrollments) of Seychelles in 1999 to that in 2004?
Your answer should be compact. 0.96. What is the ratio of the Completion rate(% of total enrollments) of Cuba in 1999 to that in 2005?
Provide a short and direct response. 1.03. What is the ratio of the Completion rate(% of total enrollments) in Paraguay in 1999 to that in 2005?
Keep it short and to the point. 0.94. What is the ratio of the Completion rate(% of total enrollments) in Seychelles in 1999 to that in 2005?
Provide a short and direct response. 0.87. What is the ratio of the Completion rate(% of total enrollments) in Uzbekistan in 1999 to that in 2005?
Make the answer very short. 0.99. What is the ratio of the Completion rate(% of total enrollments) of Seychelles in 2000 to that in 2001?
Your response must be concise. 0.94. What is the ratio of the Completion rate(% of total enrollments) of Uzbekistan in 2000 to that in 2001?
Ensure brevity in your answer.  0.95. What is the ratio of the Completion rate(% of total enrollments) of Cuba in 2000 to that in 2002?
Give a very brief answer. 0.96. What is the ratio of the Completion rate(% of total enrollments) in Paraguay in 2000 to that in 2002?
Provide a short and direct response. 0.98. What is the ratio of the Completion rate(% of total enrollments) of Seychelles in 2000 to that in 2002?
Your response must be concise. 0.93. What is the ratio of the Completion rate(% of total enrollments) of Uzbekistan in 2000 to that in 2002?
Your answer should be very brief. 0.93. What is the ratio of the Completion rate(% of total enrollments) in Cuba in 2000 to that in 2003?
Keep it short and to the point. 1.01. What is the ratio of the Completion rate(% of total enrollments) of Paraguay in 2000 to that in 2003?
Keep it short and to the point. 0.96. What is the ratio of the Completion rate(% of total enrollments) in Seychelles in 2000 to that in 2003?
Your answer should be compact. 0.92. What is the ratio of the Completion rate(% of total enrollments) of Uzbekistan in 2000 to that in 2003?
Keep it short and to the point. 0.98. What is the ratio of the Completion rate(% of total enrollments) of Cuba in 2000 to that in 2004?
Ensure brevity in your answer.  1.05. What is the ratio of the Completion rate(% of total enrollments) of Paraguay in 2000 to that in 2004?
Offer a very short reply. 0.97. What is the ratio of the Completion rate(% of total enrollments) of Seychelles in 2000 to that in 2004?
Provide a short and direct response. 0.94. What is the ratio of the Completion rate(% of total enrollments) in Cuba in 2000 to that in 2005?
Offer a very short reply. 1.05. What is the ratio of the Completion rate(% of total enrollments) in Paraguay in 2000 to that in 2005?
Your response must be concise. 0.97. What is the ratio of the Completion rate(% of total enrollments) in Seychelles in 2000 to that in 2005?
Make the answer very short. 0.85. What is the ratio of the Completion rate(% of total enrollments) of Uzbekistan in 2000 to that in 2005?
Make the answer very short. 0.98. What is the ratio of the Completion rate(% of total enrollments) of Cuba in 2001 to that in 2002?
Your answer should be compact. 0.95. What is the ratio of the Completion rate(% of total enrollments) of Paraguay in 2001 to that in 2002?
Provide a short and direct response. 0.98. What is the ratio of the Completion rate(% of total enrollments) in Seychelles in 2001 to that in 2002?
Your answer should be very brief. 0.99. What is the ratio of the Completion rate(% of total enrollments) of Uzbekistan in 2001 to that in 2002?
Your answer should be compact. 0.98. What is the ratio of the Completion rate(% of total enrollments) in Paraguay in 2001 to that in 2003?
Your answer should be very brief. 0.96. What is the ratio of the Completion rate(% of total enrollments) of Seychelles in 2001 to that in 2003?
Make the answer very short. 0.98. What is the ratio of the Completion rate(% of total enrollments) in Uzbekistan in 2001 to that in 2003?
Offer a very short reply. 1.04. What is the ratio of the Completion rate(% of total enrollments) in Cuba in 2001 to that in 2004?
Provide a short and direct response. 1.04. What is the ratio of the Completion rate(% of total enrollments) in Paraguay in 2001 to that in 2004?
Offer a terse response. 0.97. What is the ratio of the Completion rate(% of total enrollments) in Seychelles in 2001 to that in 2004?
Provide a succinct answer. 1. What is the ratio of the Completion rate(% of total enrollments) in Uzbekistan in 2001 to that in 2004?
Keep it short and to the point. 1.06. What is the ratio of the Completion rate(% of total enrollments) in Cuba in 2001 to that in 2005?
Offer a very short reply. 1.05. What is the ratio of the Completion rate(% of total enrollments) of Paraguay in 2001 to that in 2005?
Make the answer very short. 0.97. What is the ratio of the Completion rate(% of total enrollments) in Seychelles in 2001 to that in 2005?
Give a very brief answer. 0.9. What is the ratio of the Completion rate(% of total enrollments) of Uzbekistan in 2001 to that in 2005?
Give a very brief answer. 1.04. What is the ratio of the Completion rate(% of total enrollments) of Cuba in 2002 to that in 2003?
Your answer should be very brief. 1.05. What is the ratio of the Completion rate(% of total enrollments) in Paraguay in 2002 to that in 2003?
Give a very brief answer. 0.98. What is the ratio of the Completion rate(% of total enrollments) of Seychelles in 2002 to that in 2003?
Provide a succinct answer. 0.99. What is the ratio of the Completion rate(% of total enrollments) of Uzbekistan in 2002 to that in 2003?
Provide a succinct answer. 1.06. What is the ratio of the Completion rate(% of total enrollments) of Cuba in 2002 to that in 2004?
Make the answer very short. 1.09. What is the ratio of the Completion rate(% of total enrollments) in Seychelles in 2002 to that in 2004?
Keep it short and to the point. 1.01. What is the ratio of the Completion rate(% of total enrollments) of Uzbekistan in 2002 to that in 2004?
Provide a succinct answer. 1.07. What is the ratio of the Completion rate(% of total enrollments) in Cuba in 2002 to that in 2005?
Offer a terse response. 1.1. What is the ratio of the Completion rate(% of total enrollments) in Paraguay in 2002 to that in 2005?
Keep it short and to the point. 0.99. What is the ratio of the Completion rate(% of total enrollments) in Seychelles in 2002 to that in 2005?
Provide a succinct answer. 0.91. What is the ratio of the Completion rate(% of total enrollments) in Uzbekistan in 2002 to that in 2005?
Your response must be concise. 1.05. What is the ratio of the Completion rate(% of total enrollments) of Cuba in 2003 to that in 2004?
Your answer should be very brief. 1.04. What is the ratio of the Completion rate(% of total enrollments) in Paraguay in 2003 to that in 2004?
Make the answer very short. 1.01. What is the ratio of the Completion rate(% of total enrollments) in Seychelles in 2003 to that in 2004?
Your answer should be very brief. 1.03. What is the ratio of the Completion rate(% of total enrollments) in Uzbekistan in 2003 to that in 2004?
Your answer should be compact. 1.02. What is the ratio of the Completion rate(% of total enrollments) in Cuba in 2003 to that in 2005?
Your answer should be very brief. 1.04. What is the ratio of the Completion rate(% of total enrollments) of Paraguay in 2003 to that in 2005?
Provide a short and direct response. 1.01. What is the ratio of the Completion rate(% of total enrollments) of Seychelles in 2003 to that in 2005?
Give a very brief answer. 0.92. What is the ratio of the Completion rate(% of total enrollments) of Uzbekistan in 2003 to that in 2005?
Provide a succinct answer. 1. What is the ratio of the Completion rate(% of total enrollments) of Paraguay in 2004 to that in 2005?
Keep it short and to the point. 1. What is the ratio of the Completion rate(% of total enrollments) of Seychelles in 2004 to that in 2005?
Give a very brief answer. 0.9. What is the ratio of the Completion rate(% of total enrollments) of Uzbekistan in 2004 to that in 2005?
Make the answer very short. 0.98. What is the difference between the highest and the second highest Completion rate(% of total enrollments) of Cuba?
Give a very brief answer. 4.25. What is the difference between the highest and the second highest Completion rate(% of total enrollments) in Paraguay?
Your answer should be compact. 1.01. What is the difference between the highest and the second highest Completion rate(% of total enrollments) in Seychelles?
Provide a short and direct response. 9.26. What is the difference between the highest and the second highest Completion rate(% of total enrollments) of Uzbekistan?
Your response must be concise. 1.73. What is the difference between the highest and the lowest Completion rate(% of total enrollments) in Cuba?
Offer a very short reply. 8.73. What is the difference between the highest and the lowest Completion rate(% of total enrollments) in Paraguay?
Provide a short and direct response. 6.86. What is the difference between the highest and the lowest Completion rate(% of total enrollments) in Seychelles?
Make the answer very short. 18.39. What is the difference between the highest and the lowest Completion rate(% of total enrollments) of Uzbekistan?
Ensure brevity in your answer.  7.14. 